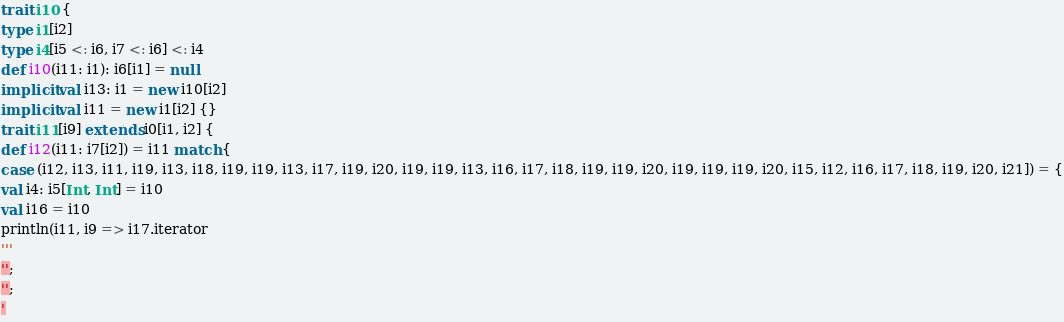<code> <loc_0><loc_0><loc_500><loc_500><_Scala_>trait i10 {
type i1[i2]
type i4[i5 <: i6, i7 <: i6] <: i4
def i10(i11: i1): i6[i1] = null
implicit val i13: i1 = new i10[i2]
implicit val i11 = new i1[i2] {}
trait i11[i9] extends i0[i1, i2] {
def i12(i11: i7[i2]) = i11 match {
case (i12, i13, i11, i19, i13, i18, i19, i19, i13, i17, i19, i20, i19, i19, i13, i16, i17, i18, i19, i19, i20, i19, i19, i19, i20, i15, i12, i16, i17, i18, i19, i20, i21]) = {
val i4: i5[Int, Int] = i10
val i16 = i10
println(i11, i9 => i17.iterator
'''
'';
'';
'</code> 